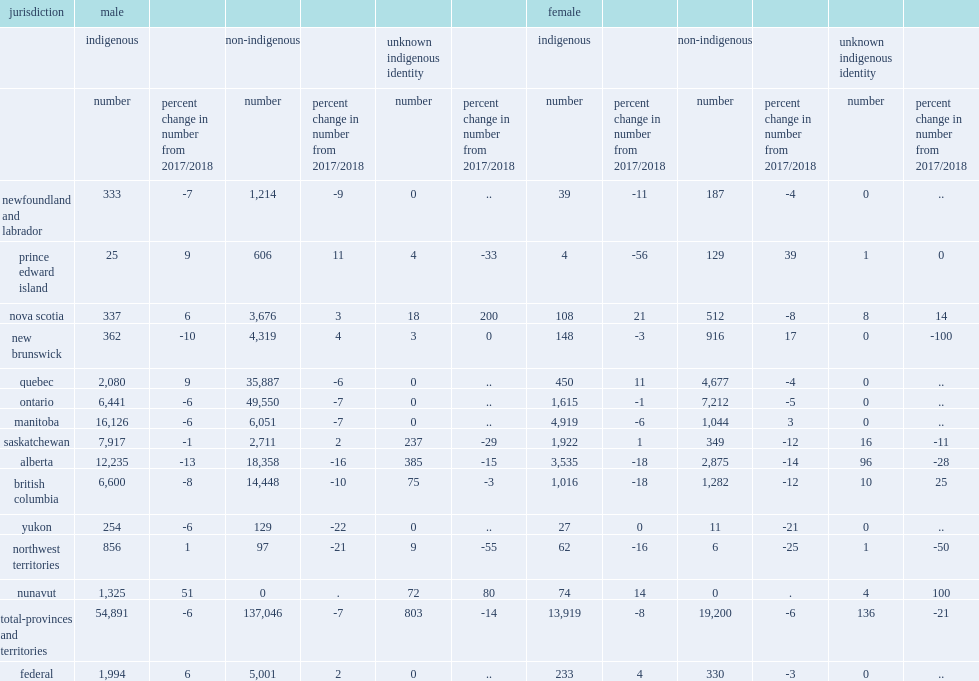In 2018/2019, what is the percentage of the number of total-provinces and terrotories adult admissions of indigenous males decreased? 6. What is the percentage of admissions of non-indigenous males decreased in the provinces and territories compared with the previous year? 7. What is the percentage of admissions of indigenous females decreased from 2017/2018? 8. What is the percentage of admissions of non-indigenous females decreased from 2017/2018? 6. Compared to 2017/2018, what is the percentage of admissions to federal corrections increased for indigenous males? 6.0. Compared to 2017/2018, what is the percentage of admissions to federal corrections increased for indigenous females ? 4.0. 